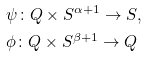Convert formula to latex. <formula><loc_0><loc_0><loc_500><loc_500>& \psi \colon Q \times S ^ { \alpha + 1 } \to S , \\ & \phi \colon Q \times S ^ { \beta + 1 } \to Q</formula> 